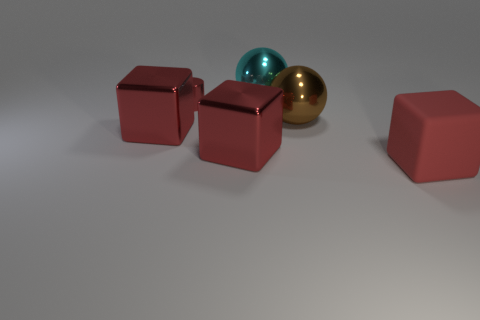How many red cubes must be subtracted to get 1 red cubes? 2 Add 1 large red things. How many objects exist? 7 Subtract all balls. How many objects are left? 4 Subtract 0 cyan blocks. How many objects are left? 6 Subtract all large red blocks. Subtract all red cylinders. How many objects are left? 2 Add 3 metal cubes. How many metal cubes are left? 5 Add 2 large metallic blocks. How many large metallic blocks exist? 4 